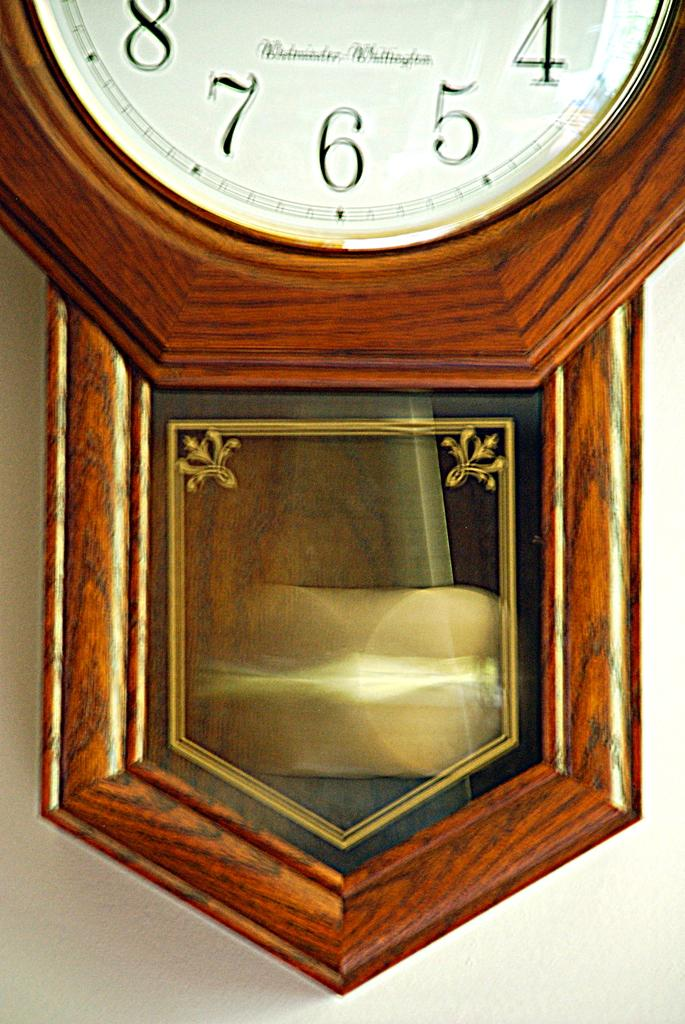<image>
Render a clear and concise summary of the photo. An old fashioned clock is fixed to the wall and on it's face reads the company's name: Westminster-Willington. 